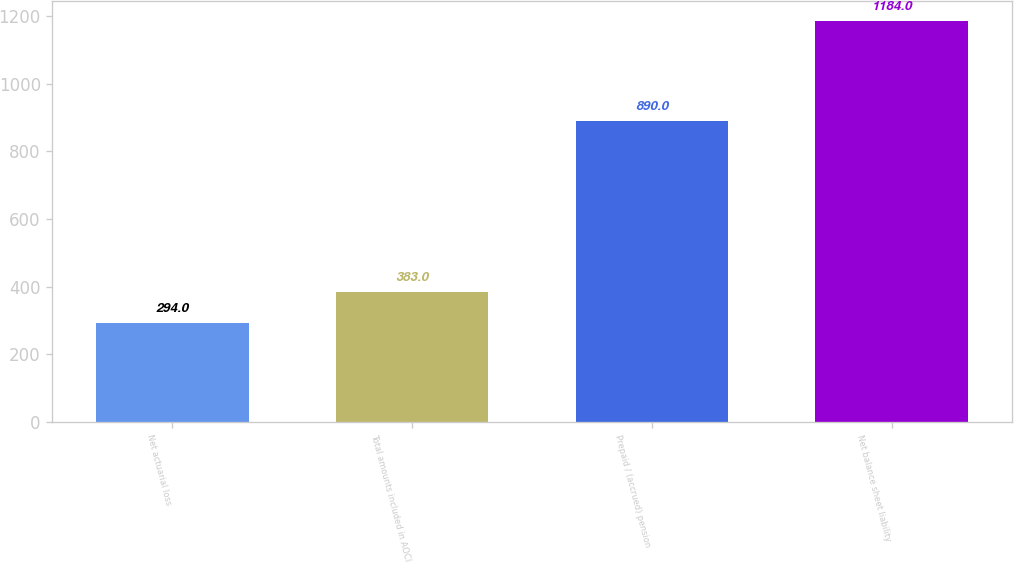Convert chart to OTSL. <chart><loc_0><loc_0><loc_500><loc_500><bar_chart><fcel>Net actuarial loss<fcel>Total amounts included in AOCI<fcel>Prepaid / (accrued) pension<fcel>Net balance sheet liability<nl><fcel>294<fcel>383<fcel>890<fcel>1184<nl></chart> 